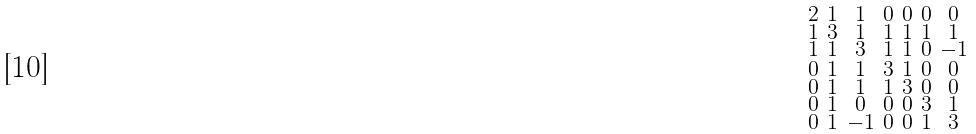<formula> <loc_0><loc_0><loc_500><loc_500>\begin{smallmatrix} 2 & 1 & 1 & 0 & 0 & 0 & 0 \\ 1 & 3 & 1 & 1 & 1 & 1 & 1 \\ 1 & 1 & 3 & 1 & 1 & 0 & - 1 \\ 0 & 1 & 1 & 3 & 1 & 0 & 0 \\ 0 & 1 & 1 & 1 & 3 & 0 & 0 \\ 0 & 1 & 0 & 0 & 0 & 3 & 1 \\ 0 & 1 & - 1 & 0 & 0 & 1 & 3 \end{smallmatrix}</formula> 